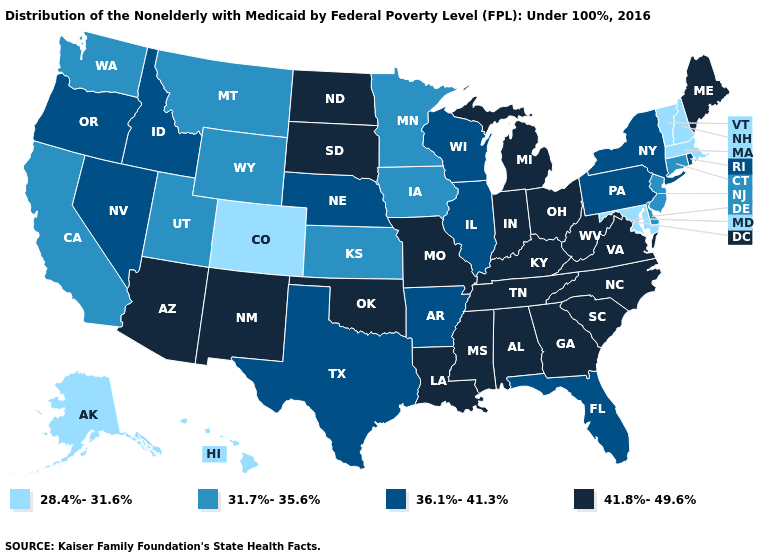Does the map have missing data?
Be succinct. No. Name the states that have a value in the range 36.1%-41.3%?
Give a very brief answer. Arkansas, Florida, Idaho, Illinois, Nebraska, Nevada, New York, Oregon, Pennsylvania, Rhode Island, Texas, Wisconsin. Is the legend a continuous bar?
Give a very brief answer. No. Does Oklahoma have a lower value than Vermont?
Concise answer only. No. Which states hav the highest value in the South?
Answer briefly. Alabama, Georgia, Kentucky, Louisiana, Mississippi, North Carolina, Oklahoma, South Carolina, Tennessee, Virginia, West Virginia. Does the first symbol in the legend represent the smallest category?
Short answer required. Yes. Name the states that have a value in the range 28.4%-31.6%?
Answer briefly. Alaska, Colorado, Hawaii, Maryland, Massachusetts, New Hampshire, Vermont. What is the value of Vermont?
Write a very short answer. 28.4%-31.6%. What is the value of Washington?
Keep it brief. 31.7%-35.6%. Name the states that have a value in the range 36.1%-41.3%?
Give a very brief answer. Arkansas, Florida, Idaho, Illinois, Nebraska, Nevada, New York, Oregon, Pennsylvania, Rhode Island, Texas, Wisconsin. Name the states that have a value in the range 36.1%-41.3%?
Quick response, please. Arkansas, Florida, Idaho, Illinois, Nebraska, Nevada, New York, Oregon, Pennsylvania, Rhode Island, Texas, Wisconsin. How many symbols are there in the legend?
Short answer required. 4. Name the states that have a value in the range 41.8%-49.6%?
Concise answer only. Alabama, Arizona, Georgia, Indiana, Kentucky, Louisiana, Maine, Michigan, Mississippi, Missouri, New Mexico, North Carolina, North Dakota, Ohio, Oklahoma, South Carolina, South Dakota, Tennessee, Virginia, West Virginia. Among the states that border Connecticut , which have the highest value?
Answer briefly. New York, Rhode Island. What is the lowest value in the USA?
Short answer required. 28.4%-31.6%. 